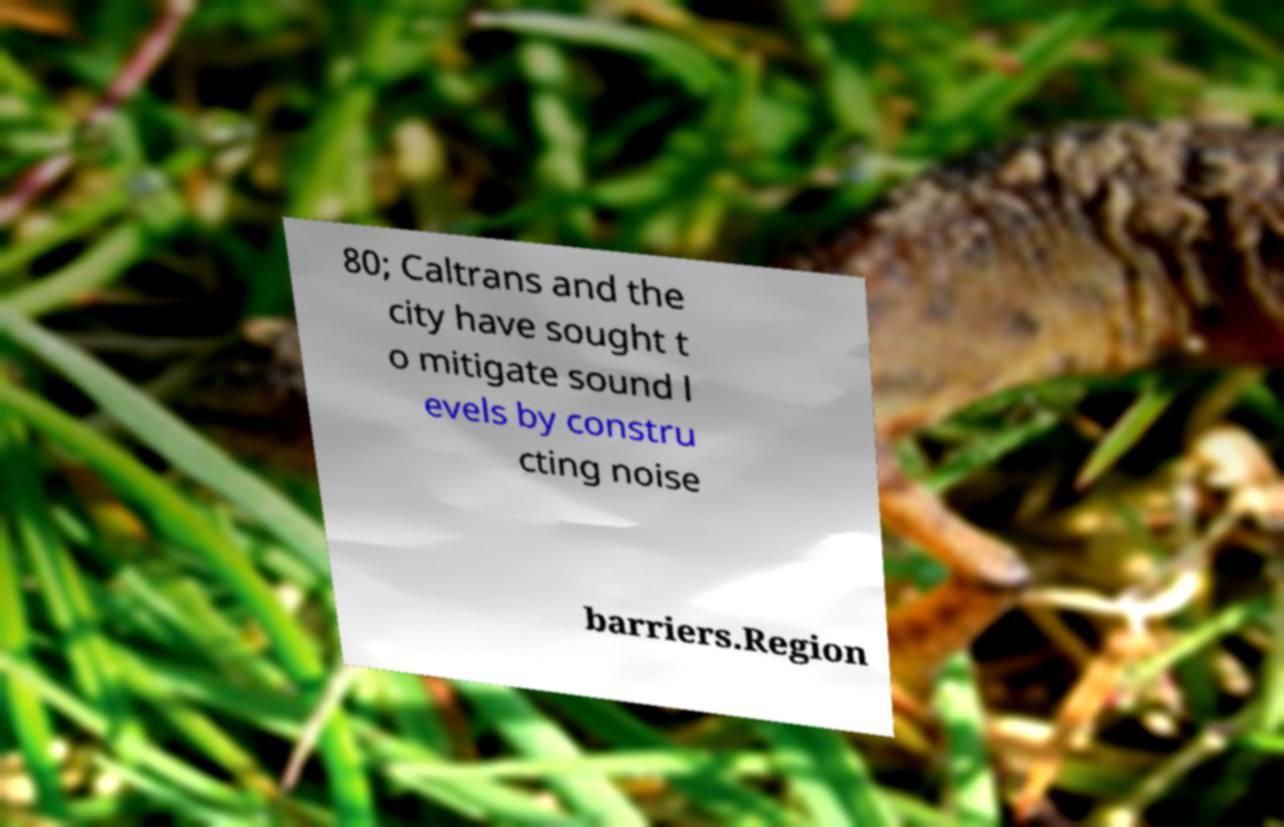Please read and relay the text visible in this image. What does it say? 80; Caltrans and the city have sought t o mitigate sound l evels by constru cting noise barriers.Region 